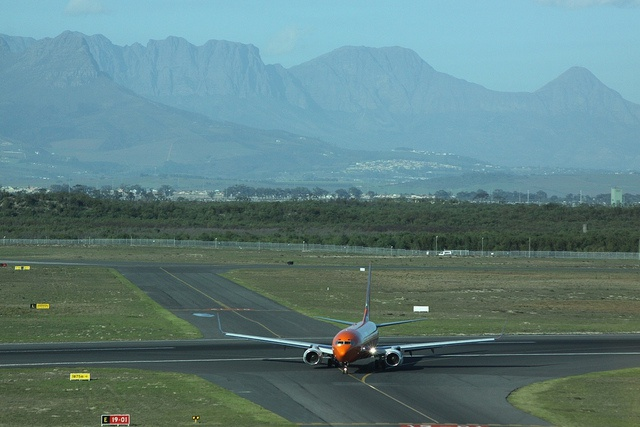Describe the objects in this image and their specific colors. I can see a airplane in lightblue, black, gray, and purple tones in this image. 